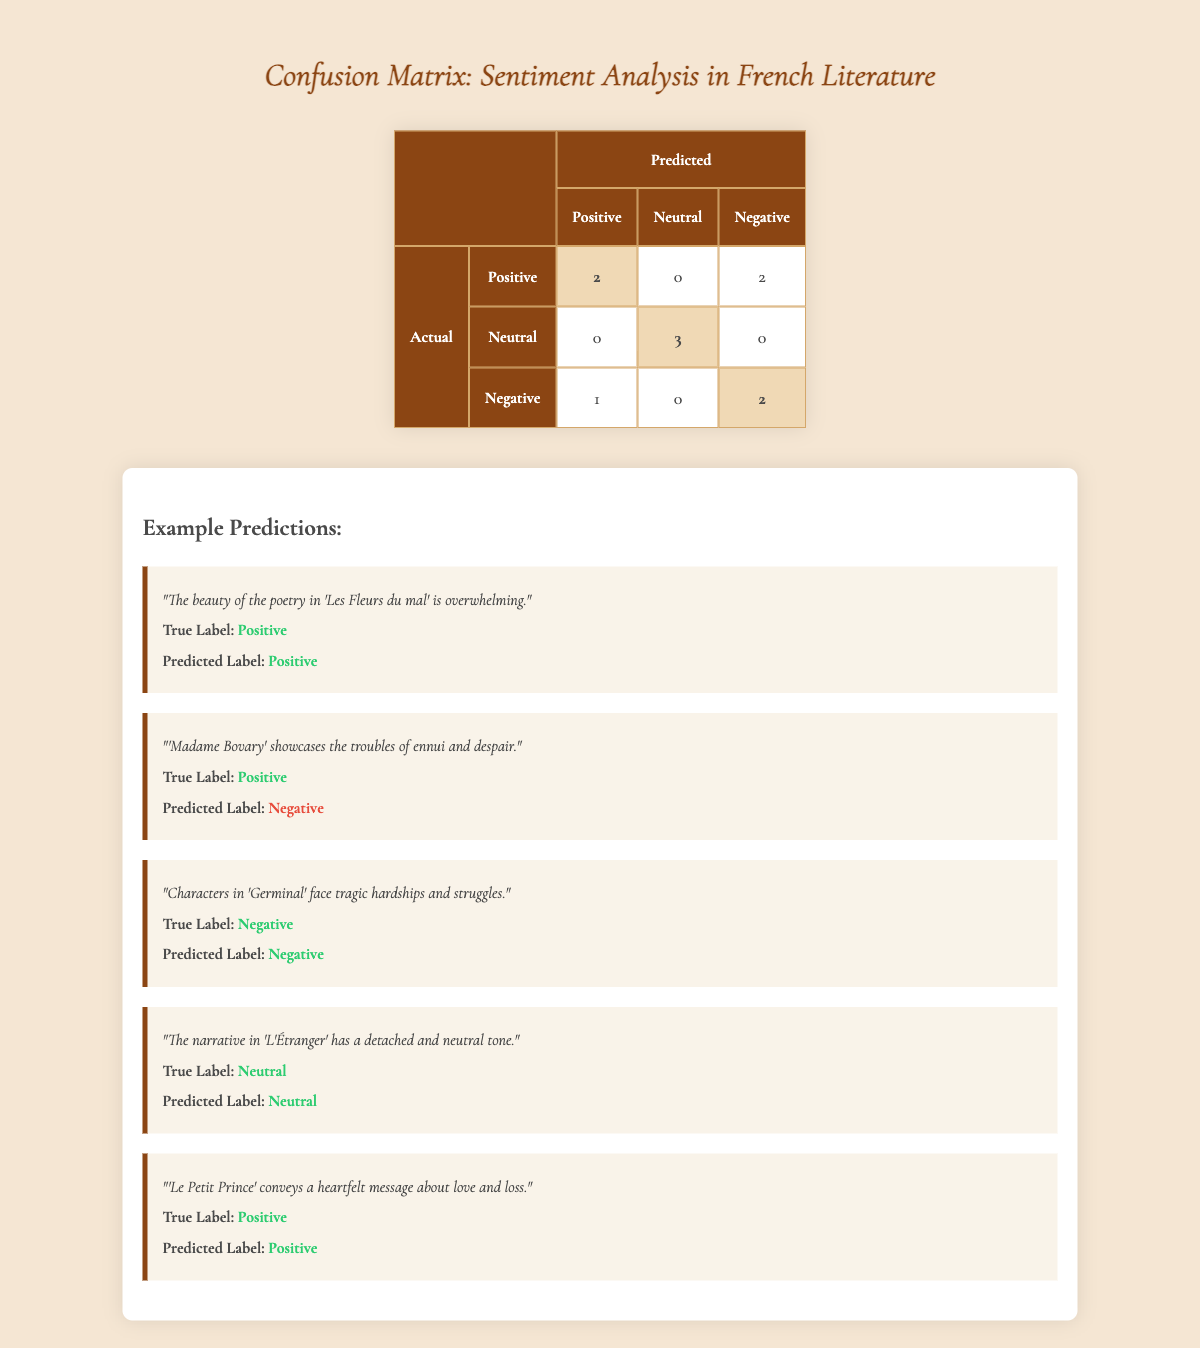What is the number of true positives for the Positive category? The true positives are the instances where the actual label is Positive and the predicted label is also Positive. Referring to the table, we find that there are 2 true positives for the Positive category.
Answer: 2 How many instances were mislabeled as Negative when they were actually Positive? Looking at the table, there is 1 instance where the true label is Positive but the predicted label is Negative. Therefore, there was 1 mislabeling in this case.
Answer: 1 What is the total number of instances classified as Neutral? In the confusion matrix, the actual class "Neutral" has a correct prediction of 3 (True Neutral) and 0 for misclassifications (Predicted Neutral and others). Therefore, the total number of instances classified as Neutral is 3.
Answer: 3 Is the number of instances mislabeled as Positive when they were actually Negative greater than the instances mislabeled as Negative when they were actually Positive? There is 1 instance mislabeled as Positive (the actual Negative labeled as Positive) and 2 instances mislabeled as Negative (1 Positive and 1 Neutral). Since 2 is greater than 1, the answer is yes.
Answer: Yes What is the proportion of correct predictions (both True Positives and True Negatives) among the total predictions? True positives for Positive = 2, True positives for Negative = 2, and True positives for Neutral = 3. The total correct predictions are 2 + 2 + 3 = 7. The total predictions are 10. Thus, the proportion of correct predictions is 7/10 = 0.7 or 70%.
Answer: 0.7 (70%) How many total instances were classified as Negative? Referring to the table, we see that for the Negative category, there are 2 true negatives and 2 misclassifications (+1 for the Positive misclassified as Negative) which makes a total of 2 + 1 (from Neutral) = 3 cases measured for the Negative category.
Answer: 3 